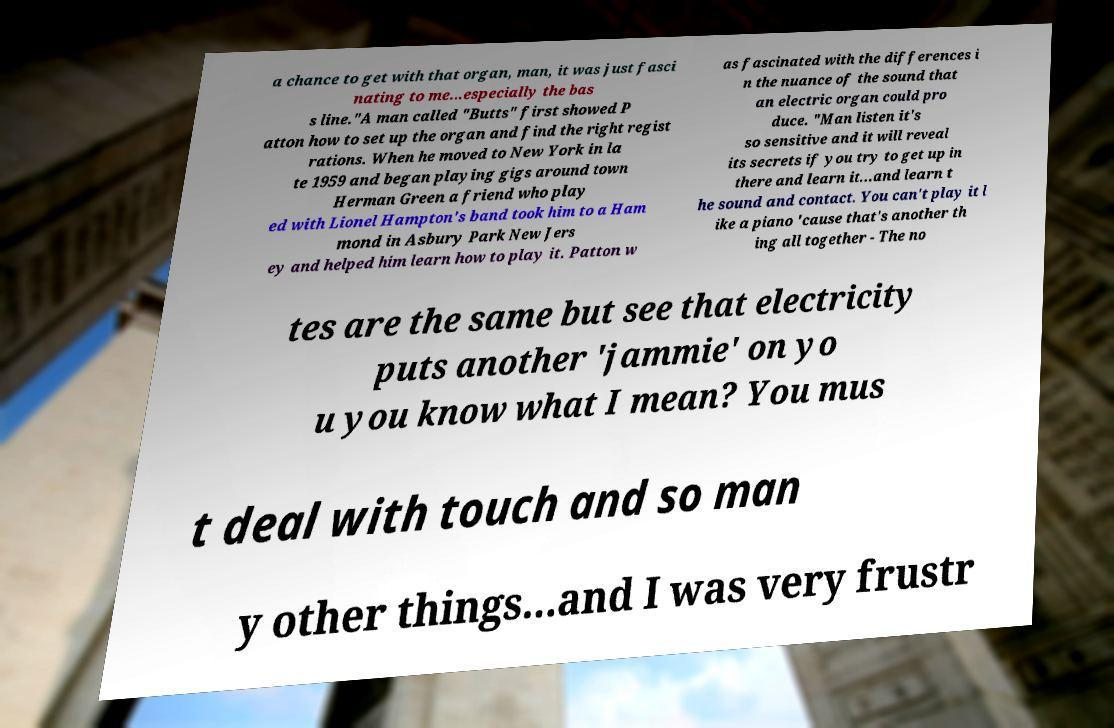Can you read and provide the text displayed in the image?This photo seems to have some interesting text. Can you extract and type it out for me? a chance to get with that organ, man, it was just fasci nating to me...especially the bas s line."A man called "Butts" first showed P atton how to set up the organ and find the right regist rations. When he moved to New York in la te 1959 and began playing gigs around town Herman Green a friend who play ed with Lionel Hampton's band took him to a Ham mond in Asbury Park New Jers ey and helped him learn how to play it. Patton w as fascinated with the differences i n the nuance of the sound that an electric organ could pro duce. "Man listen it's so sensitive and it will reveal its secrets if you try to get up in there and learn it...and learn t he sound and contact. You can't play it l ike a piano 'cause that's another th ing all together - The no tes are the same but see that electricity puts another 'jammie' on yo u you know what I mean? You mus t deal with touch and so man y other things...and I was very frustr 